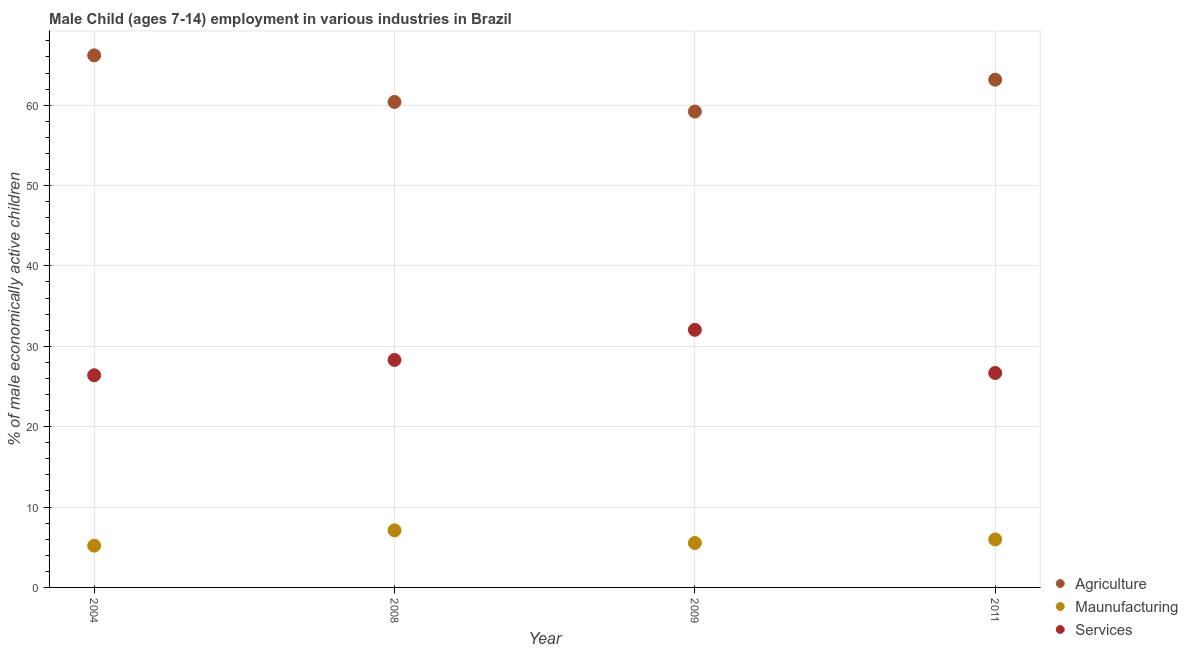How many different coloured dotlines are there?
Offer a terse response. 3. What is the percentage of economically active children in manufacturing in 2009?
Offer a terse response. 5.53. Across all years, what is the maximum percentage of economically active children in services?
Your answer should be compact. 32.05. Across all years, what is the minimum percentage of economically active children in manufacturing?
Give a very brief answer. 5.2. In which year was the percentage of economically active children in services minimum?
Offer a very short reply. 2004. What is the total percentage of economically active children in services in the graph?
Your answer should be very brief. 113.43. What is the difference between the percentage of economically active children in manufacturing in 2004 and that in 2008?
Give a very brief answer. -1.9. What is the difference between the percentage of economically active children in agriculture in 2009 and the percentage of economically active children in manufacturing in 2004?
Provide a short and direct response. 54.01. What is the average percentage of economically active children in services per year?
Your response must be concise. 28.36. In the year 2011, what is the difference between the percentage of economically active children in manufacturing and percentage of economically active children in services?
Keep it short and to the point. -20.71. What is the ratio of the percentage of economically active children in agriculture in 2004 to that in 2008?
Give a very brief answer. 1.1. Is the difference between the percentage of economically active children in services in 2008 and 2011 greater than the difference between the percentage of economically active children in manufacturing in 2008 and 2011?
Offer a terse response. Yes. What is the difference between the highest and the second highest percentage of economically active children in services?
Provide a short and direct response. 3.75. What is the difference between the highest and the lowest percentage of economically active children in services?
Ensure brevity in your answer.  5.65. In how many years, is the percentage of economically active children in services greater than the average percentage of economically active children in services taken over all years?
Offer a very short reply. 1. Is the sum of the percentage of economically active children in services in 2008 and 2009 greater than the maximum percentage of economically active children in agriculture across all years?
Ensure brevity in your answer.  No. Does the percentage of economically active children in services monotonically increase over the years?
Provide a short and direct response. No. Is the percentage of economically active children in agriculture strictly greater than the percentage of economically active children in services over the years?
Make the answer very short. Yes. How many dotlines are there?
Your answer should be very brief. 3. What is the difference between two consecutive major ticks on the Y-axis?
Provide a succinct answer. 10. Does the graph contain grids?
Offer a very short reply. Yes. Where does the legend appear in the graph?
Your answer should be very brief. Bottom right. How many legend labels are there?
Provide a succinct answer. 3. What is the title of the graph?
Offer a terse response. Male Child (ages 7-14) employment in various industries in Brazil. Does "Neonatal" appear as one of the legend labels in the graph?
Provide a succinct answer. No. What is the label or title of the Y-axis?
Ensure brevity in your answer.  % of male economically active children. What is the % of male economically active children of Agriculture in 2004?
Provide a succinct answer. 66.2. What is the % of male economically active children in Maunufacturing in 2004?
Give a very brief answer. 5.2. What is the % of male economically active children of Services in 2004?
Your response must be concise. 26.4. What is the % of male economically active children in Agriculture in 2008?
Provide a succinct answer. 60.4. What is the % of male economically active children of Services in 2008?
Keep it short and to the point. 28.3. What is the % of male economically active children of Agriculture in 2009?
Keep it short and to the point. 59.21. What is the % of male economically active children in Maunufacturing in 2009?
Your answer should be very brief. 5.53. What is the % of male economically active children in Services in 2009?
Give a very brief answer. 32.05. What is the % of male economically active children in Agriculture in 2011?
Your answer should be compact. 63.17. What is the % of male economically active children of Maunufacturing in 2011?
Keep it short and to the point. 5.97. What is the % of male economically active children of Services in 2011?
Make the answer very short. 26.68. Across all years, what is the maximum % of male economically active children of Agriculture?
Give a very brief answer. 66.2. Across all years, what is the maximum % of male economically active children of Maunufacturing?
Keep it short and to the point. 7.1. Across all years, what is the maximum % of male economically active children in Services?
Provide a short and direct response. 32.05. Across all years, what is the minimum % of male economically active children of Agriculture?
Make the answer very short. 59.21. Across all years, what is the minimum % of male economically active children in Maunufacturing?
Give a very brief answer. 5.2. Across all years, what is the minimum % of male economically active children of Services?
Make the answer very short. 26.4. What is the total % of male economically active children in Agriculture in the graph?
Your answer should be compact. 248.98. What is the total % of male economically active children of Maunufacturing in the graph?
Your answer should be very brief. 23.8. What is the total % of male economically active children in Services in the graph?
Give a very brief answer. 113.43. What is the difference between the % of male economically active children in Agriculture in 2004 and that in 2008?
Provide a short and direct response. 5.8. What is the difference between the % of male economically active children in Services in 2004 and that in 2008?
Give a very brief answer. -1.9. What is the difference between the % of male economically active children of Agriculture in 2004 and that in 2009?
Your answer should be compact. 6.99. What is the difference between the % of male economically active children in Maunufacturing in 2004 and that in 2009?
Your response must be concise. -0.33. What is the difference between the % of male economically active children of Services in 2004 and that in 2009?
Make the answer very short. -5.65. What is the difference between the % of male economically active children of Agriculture in 2004 and that in 2011?
Keep it short and to the point. 3.03. What is the difference between the % of male economically active children in Maunufacturing in 2004 and that in 2011?
Offer a terse response. -0.77. What is the difference between the % of male economically active children of Services in 2004 and that in 2011?
Provide a succinct answer. -0.28. What is the difference between the % of male economically active children of Agriculture in 2008 and that in 2009?
Offer a very short reply. 1.19. What is the difference between the % of male economically active children of Maunufacturing in 2008 and that in 2009?
Provide a succinct answer. 1.57. What is the difference between the % of male economically active children in Services in 2008 and that in 2009?
Offer a terse response. -3.75. What is the difference between the % of male economically active children of Agriculture in 2008 and that in 2011?
Your response must be concise. -2.77. What is the difference between the % of male economically active children of Maunufacturing in 2008 and that in 2011?
Provide a short and direct response. 1.13. What is the difference between the % of male economically active children in Services in 2008 and that in 2011?
Offer a terse response. 1.62. What is the difference between the % of male economically active children in Agriculture in 2009 and that in 2011?
Your response must be concise. -3.96. What is the difference between the % of male economically active children in Maunufacturing in 2009 and that in 2011?
Make the answer very short. -0.44. What is the difference between the % of male economically active children of Services in 2009 and that in 2011?
Provide a short and direct response. 5.37. What is the difference between the % of male economically active children in Agriculture in 2004 and the % of male economically active children in Maunufacturing in 2008?
Give a very brief answer. 59.1. What is the difference between the % of male economically active children of Agriculture in 2004 and the % of male economically active children of Services in 2008?
Provide a succinct answer. 37.9. What is the difference between the % of male economically active children in Maunufacturing in 2004 and the % of male economically active children in Services in 2008?
Your answer should be compact. -23.1. What is the difference between the % of male economically active children of Agriculture in 2004 and the % of male economically active children of Maunufacturing in 2009?
Give a very brief answer. 60.67. What is the difference between the % of male economically active children in Agriculture in 2004 and the % of male economically active children in Services in 2009?
Your answer should be very brief. 34.15. What is the difference between the % of male economically active children in Maunufacturing in 2004 and the % of male economically active children in Services in 2009?
Keep it short and to the point. -26.85. What is the difference between the % of male economically active children in Agriculture in 2004 and the % of male economically active children in Maunufacturing in 2011?
Offer a very short reply. 60.23. What is the difference between the % of male economically active children in Agriculture in 2004 and the % of male economically active children in Services in 2011?
Keep it short and to the point. 39.52. What is the difference between the % of male economically active children of Maunufacturing in 2004 and the % of male economically active children of Services in 2011?
Make the answer very short. -21.48. What is the difference between the % of male economically active children in Agriculture in 2008 and the % of male economically active children in Maunufacturing in 2009?
Your answer should be very brief. 54.87. What is the difference between the % of male economically active children in Agriculture in 2008 and the % of male economically active children in Services in 2009?
Offer a very short reply. 28.35. What is the difference between the % of male economically active children of Maunufacturing in 2008 and the % of male economically active children of Services in 2009?
Your answer should be very brief. -24.95. What is the difference between the % of male economically active children in Agriculture in 2008 and the % of male economically active children in Maunufacturing in 2011?
Make the answer very short. 54.43. What is the difference between the % of male economically active children of Agriculture in 2008 and the % of male economically active children of Services in 2011?
Provide a succinct answer. 33.72. What is the difference between the % of male economically active children in Maunufacturing in 2008 and the % of male economically active children in Services in 2011?
Offer a very short reply. -19.58. What is the difference between the % of male economically active children in Agriculture in 2009 and the % of male economically active children in Maunufacturing in 2011?
Your answer should be compact. 53.24. What is the difference between the % of male economically active children in Agriculture in 2009 and the % of male economically active children in Services in 2011?
Your answer should be very brief. 32.53. What is the difference between the % of male economically active children in Maunufacturing in 2009 and the % of male economically active children in Services in 2011?
Your answer should be very brief. -21.15. What is the average % of male economically active children of Agriculture per year?
Give a very brief answer. 62.24. What is the average % of male economically active children in Maunufacturing per year?
Ensure brevity in your answer.  5.95. What is the average % of male economically active children in Services per year?
Make the answer very short. 28.36. In the year 2004, what is the difference between the % of male economically active children in Agriculture and % of male economically active children in Maunufacturing?
Keep it short and to the point. 61. In the year 2004, what is the difference between the % of male economically active children of Agriculture and % of male economically active children of Services?
Your answer should be very brief. 39.8. In the year 2004, what is the difference between the % of male economically active children of Maunufacturing and % of male economically active children of Services?
Offer a terse response. -21.2. In the year 2008, what is the difference between the % of male economically active children of Agriculture and % of male economically active children of Maunufacturing?
Offer a very short reply. 53.3. In the year 2008, what is the difference between the % of male economically active children of Agriculture and % of male economically active children of Services?
Keep it short and to the point. 32.1. In the year 2008, what is the difference between the % of male economically active children in Maunufacturing and % of male economically active children in Services?
Provide a short and direct response. -21.2. In the year 2009, what is the difference between the % of male economically active children in Agriculture and % of male economically active children in Maunufacturing?
Ensure brevity in your answer.  53.68. In the year 2009, what is the difference between the % of male economically active children of Agriculture and % of male economically active children of Services?
Provide a short and direct response. 27.16. In the year 2009, what is the difference between the % of male economically active children of Maunufacturing and % of male economically active children of Services?
Offer a terse response. -26.52. In the year 2011, what is the difference between the % of male economically active children of Agriculture and % of male economically active children of Maunufacturing?
Your answer should be compact. 57.2. In the year 2011, what is the difference between the % of male economically active children of Agriculture and % of male economically active children of Services?
Provide a succinct answer. 36.49. In the year 2011, what is the difference between the % of male economically active children in Maunufacturing and % of male economically active children in Services?
Offer a terse response. -20.71. What is the ratio of the % of male economically active children in Agriculture in 2004 to that in 2008?
Your response must be concise. 1.1. What is the ratio of the % of male economically active children in Maunufacturing in 2004 to that in 2008?
Provide a succinct answer. 0.73. What is the ratio of the % of male economically active children of Services in 2004 to that in 2008?
Provide a succinct answer. 0.93. What is the ratio of the % of male economically active children in Agriculture in 2004 to that in 2009?
Your answer should be compact. 1.12. What is the ratio of the % of male economically active children of Maunufacturing in 2004 to that in 2009?
Keep it short and to the point. 0.94. What is the ratio of the % of male economically active children of Services in 2004 to that in 2009?
Your response must be concise. 0.82. What is the ratio of the % of male economically active children of Agriculture in 2004 to that in 2011?
Provide a short and direct response. 1.05. What is the ratio of the % of male economically active children of Maunufacturing in 2004 to that in 2011?
Offer a terse response. 0.87. What is the ratio of the % of male economically active children in Agriculture in 2008 to that in 2009?
Provide a succinct answer. 1.02. What is the ratio of the % of male economically active children in Maunufacturing in 2008 to that in 2009?
Provide a short and direct response. 1.28. What is the ratio of the % of male economically active children of Services in 2008 to that in 2009?
Give a very brief answer. 0.88. What is the ratio of the % of male economically active children in Agriculture in 2008 to that in 2011?
Offer a very short reply. 0.96. What is the ratio of the % of male economically active children in Maunufacturing in 2008 to that in 2011?
Provide a short and direct response. 1.19. What is the ratio of the % of male economically active children in Services in 2008 to that in 2011?
Make the answer very short. 1.06. What is the ratio of the % of male economically active children in Agriculture in 2009 to that in 2011?
Keep it short and to the point. 0.94. What is the ratio of the % of male economically active children in Maunufacturing in 2009 to that in 2011?
Ensure brevity in your answer.  0.93. What is the ratio of the % of male economically active children in Services in 2009 to that in 2011?
Offer a terse response. 1.2. What is the difference between the highest and the second highest % of male economically active children of Agriculture?
Make the answer very short. 3.03. What is the difference between the highest and the second highest % of male economically active children of Maunufacturing?
Offer a very short reply. 1.13. What is the difference between the highest and the second highest % of male economically active children of Services?
Provide a succinct answer. 3.75. What is the difference between the highest and the lowest % of male economically active children of Agriculture?
Offer a terse response. 6.99. What is the difference between the highest and the lowest % of male economically active children in Maunufacturing?
Make the answer very short. 1.9. What is the difference between the highest and the lowest % of male economically active children of Services?
Your response must be concise. 5.65. 